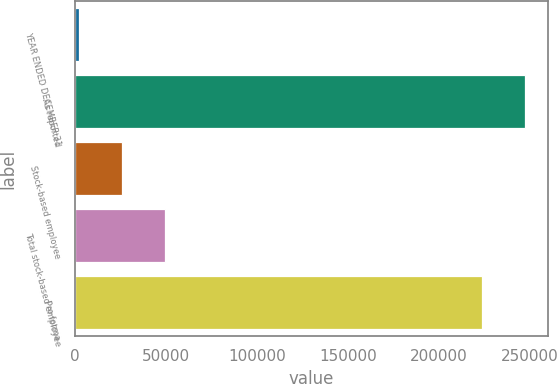<chart> <loc_0><loc_0><loc_500><loc_500><bar_chart><fcel>YEAR ENDED DECEMBER 31<fcel>As reported<fcel>Stock-based employee<fcel>Total stock-based employee<fcel>Pro forma<nl><fcel>2005<fcel>247138<fcel>25591.5<fcel>49178<fcel>223552<nl></chart> 